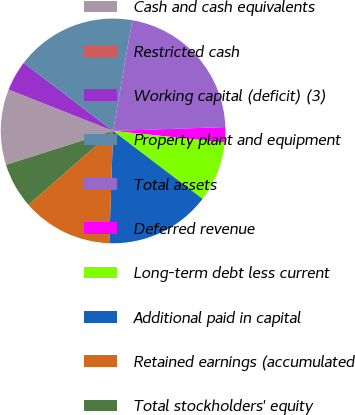Convert chart. <chart><loc_0><loc_0><loc_500><loc_500><pie_chart><fcel>Cash and cash equivalents<fcel>Restricted cash<fcel>Working capital (deficit) (3)<fcel>Property plant and equipment<fcel>Total assets<fcel>Deferred revenue<fcel>Long-term debt less current<fcel>Additional paid in capital<fcel>Retained earnings (accumulated<fcel>Total stockholders' equity<nl><fcel>10.87%<fcel>0.02%<fcel>4.36%<fcel>17.38%<fcel>21.72%<fcel>2.19%<fcel>8.7%<fcel>15.21%<fcel>13.04%<fcel>6.53%<nl></chart> 